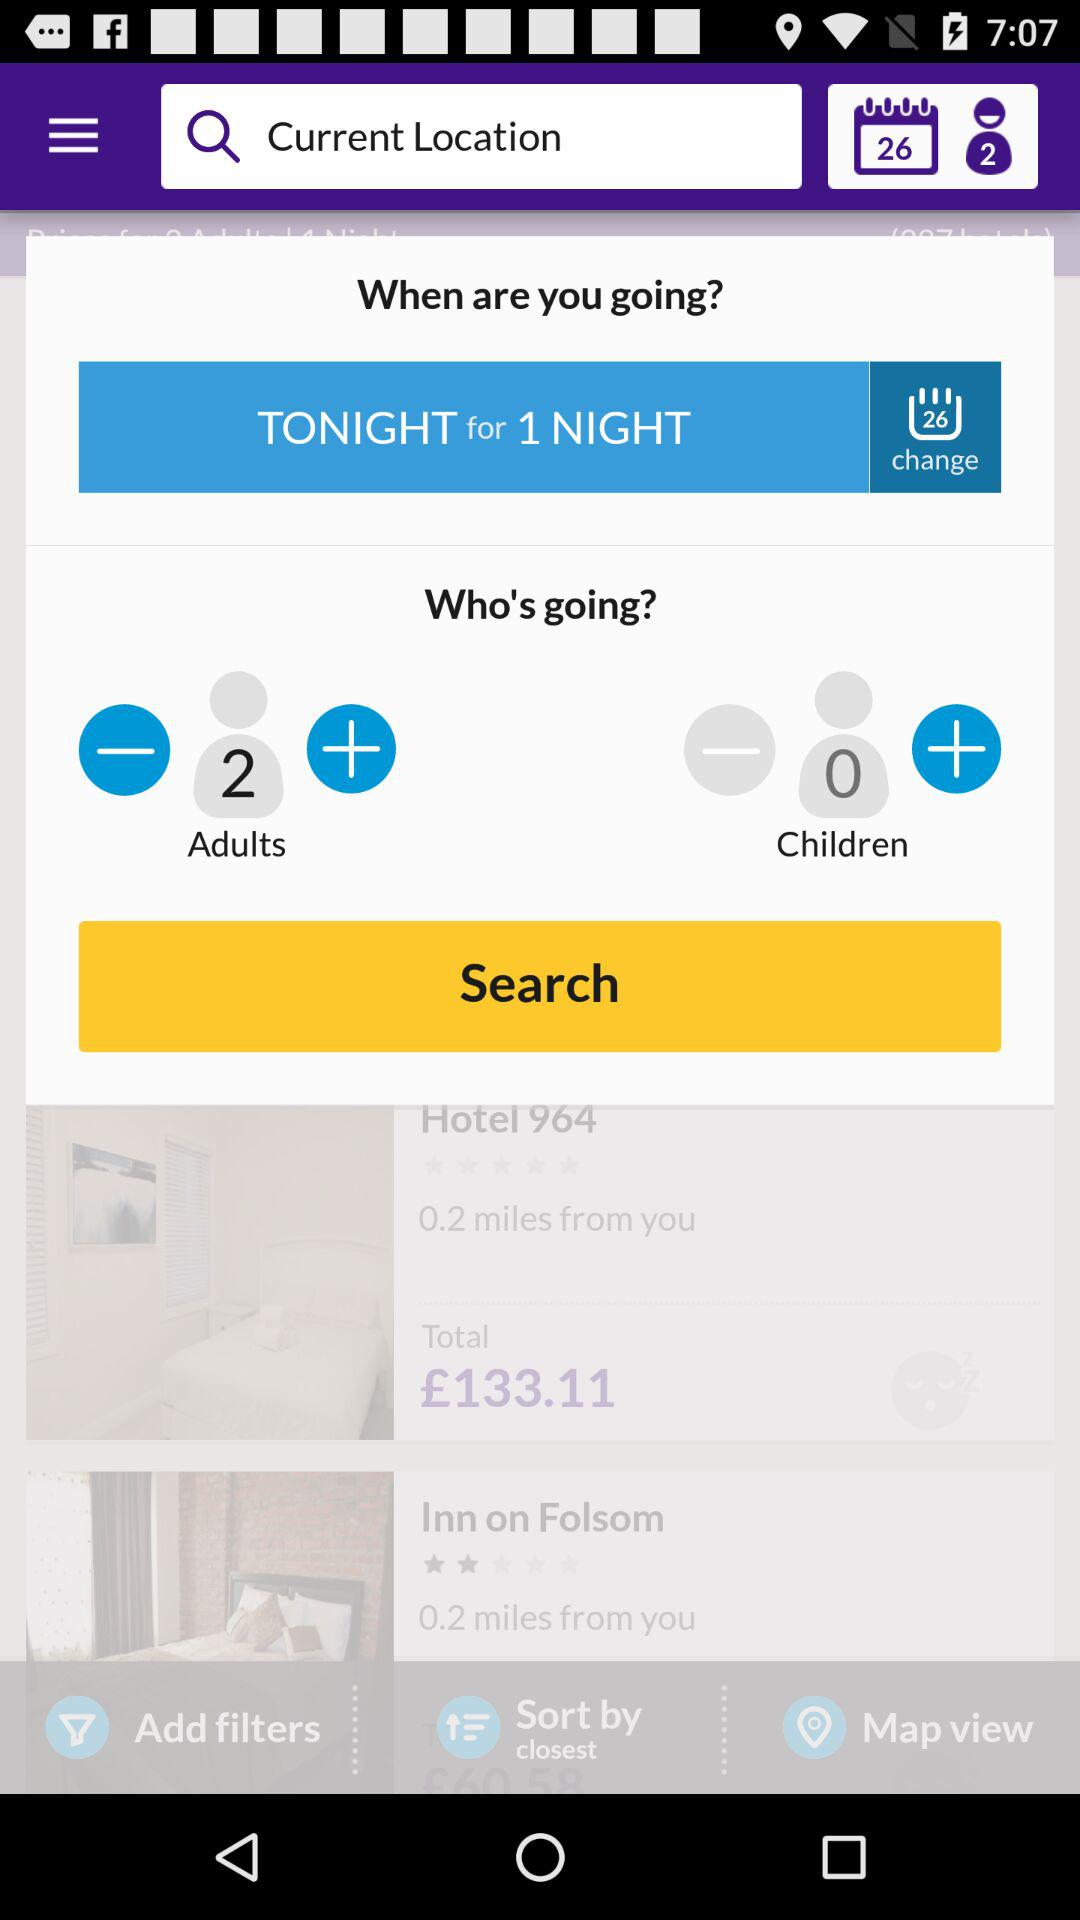What is the price of the first hotel?
Answer the question using a single word or phrase. £133.11 